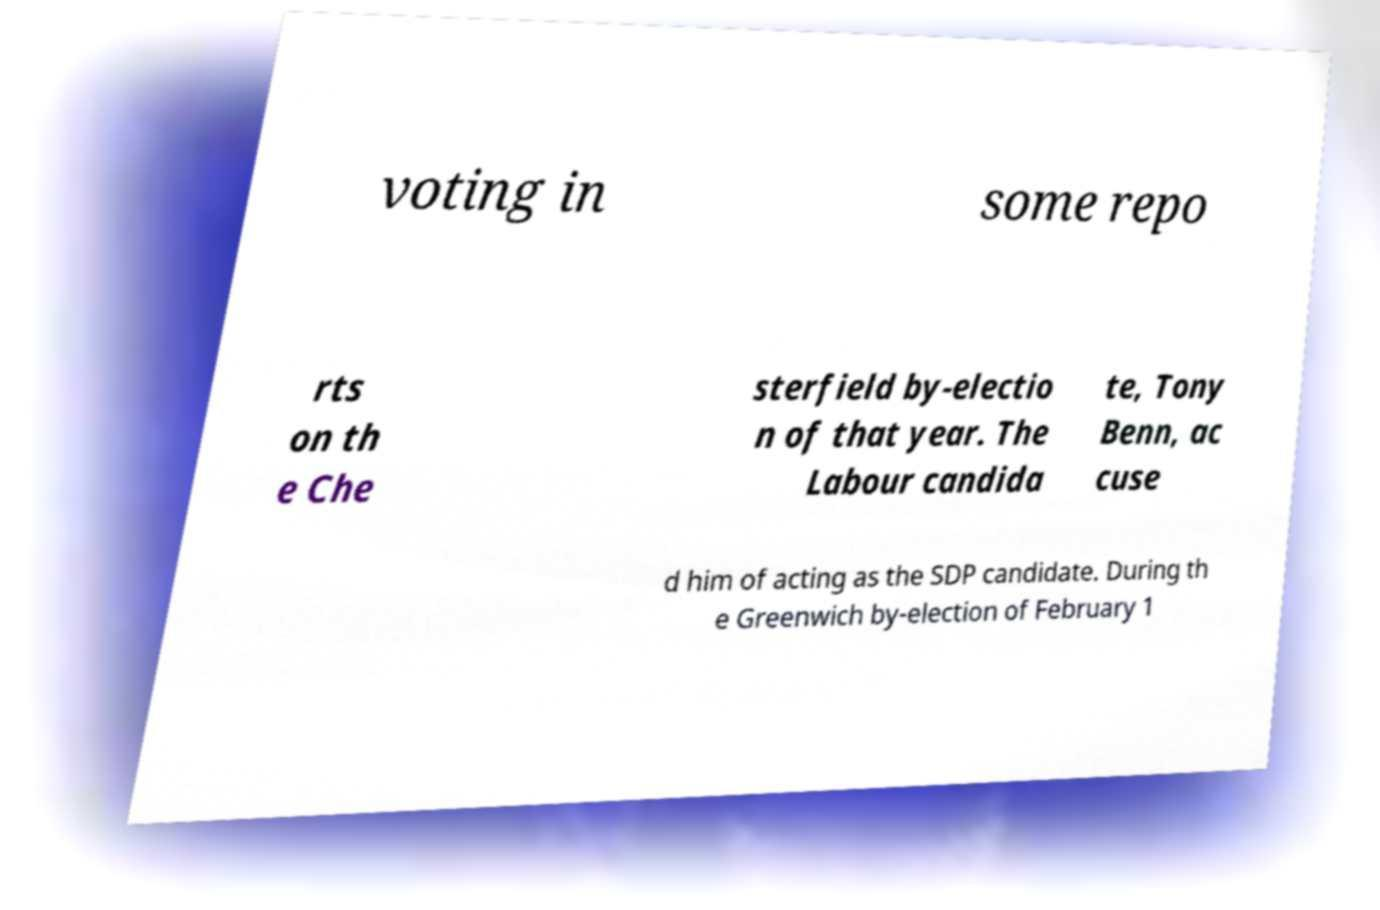There's text embedded in this image that I need extracted. Can you transcribe it verbatim? voting in some repo rts on th e Che sterfield by-electio n of that year. The Labour candida te, Tony Benn, ac cuse d him of acting as the SDP candidate. During th e Greenwich by-election of February 1 